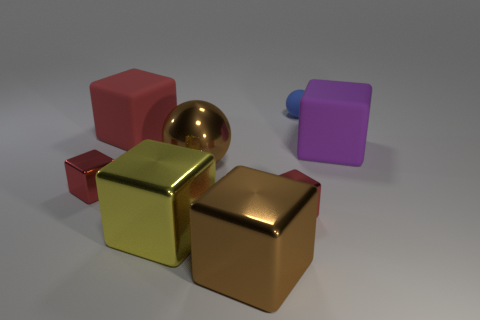Is there any pattern or consistency in how the objects are arranged? The objects are arranged in a seemingly random configuration without a discernible pattern. The placement doesn't follow any geometric or linear order, and there's a mix of orientations and angles among the objects, creating a more natural, arbitrary scene. What can you infer about the weight of these objects? Judging by their appearances, the metallic objects are likely heavier than the matte ones due to the material they resemble. However, since this is an image, I cannot assert the actual weight of the objects without more context or information on their composition. 